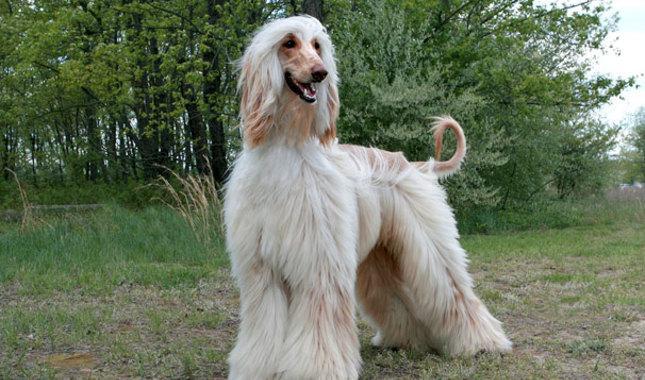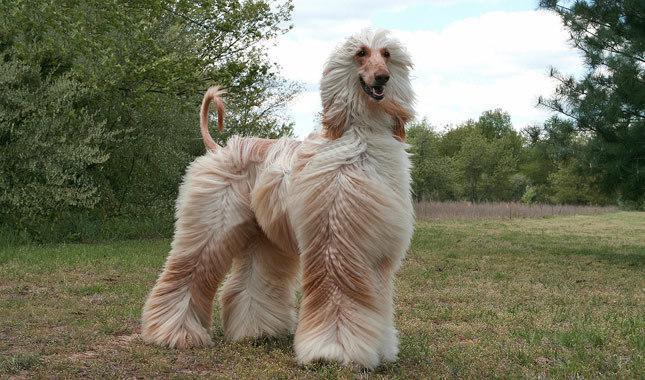The first image is the image on the left, the second image is the image on the right. Analyze the images presented: Is the assertion "Both dogs are standing on a grassy area." valid? Answer yes or no. Yes. The first image is the image on the left, the second image is the image on the right. For the images shown, is this caption "Each image shows one blonde hound with long silky hair standing on a green grassy area." true? Answer yes or no. Yes. 